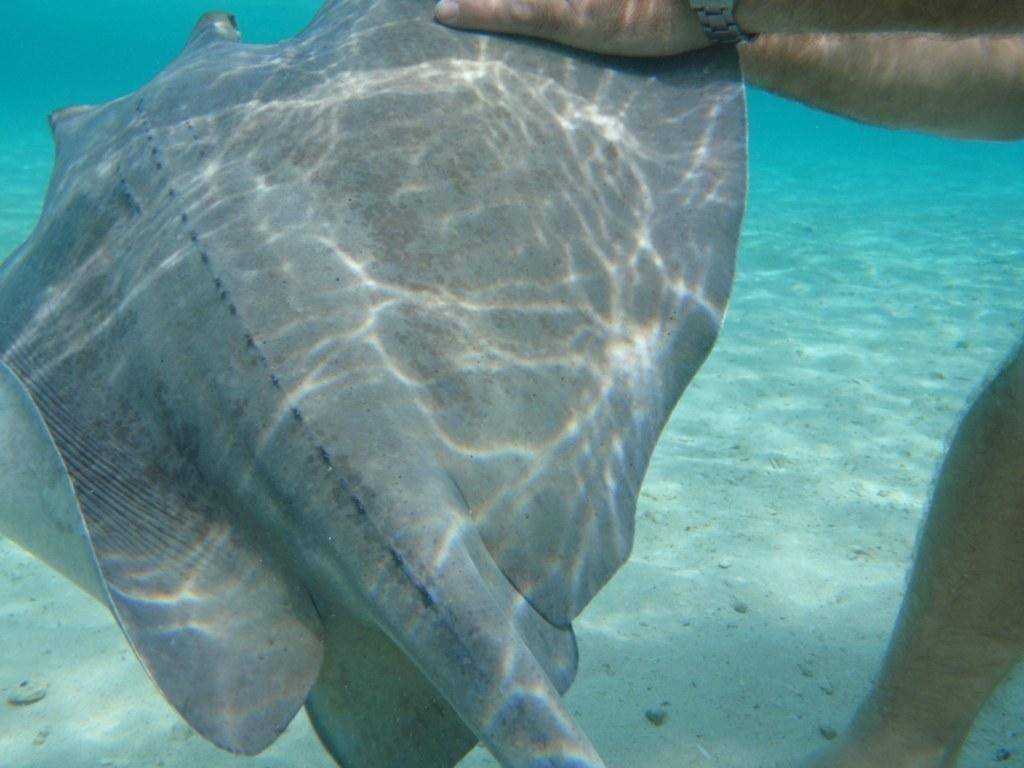What is the main subject of the image? The main subject of the image is a starfish. Where is the starfish located? The starfish is in a person's hand and in water. Can you describe any part of the person holding the starfish? Yes, a leg of the person is visible in the image. What type of soda is being advertised in the image? There is no soda or advertisement present in the image; it features a starfish in a person's hand in water. Can you tell me how fast the user is running in the image? There is no user running in the image; it shows a person holding a starfish in water. 